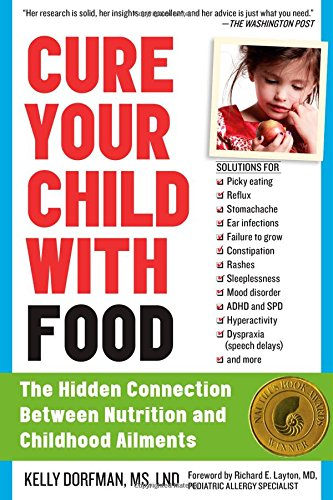What type of book is this? This is a book categorized under Health, Fitness & Dieting. It specifically targets how food can be a pivotal element in treating childhood diseases and conditions. 